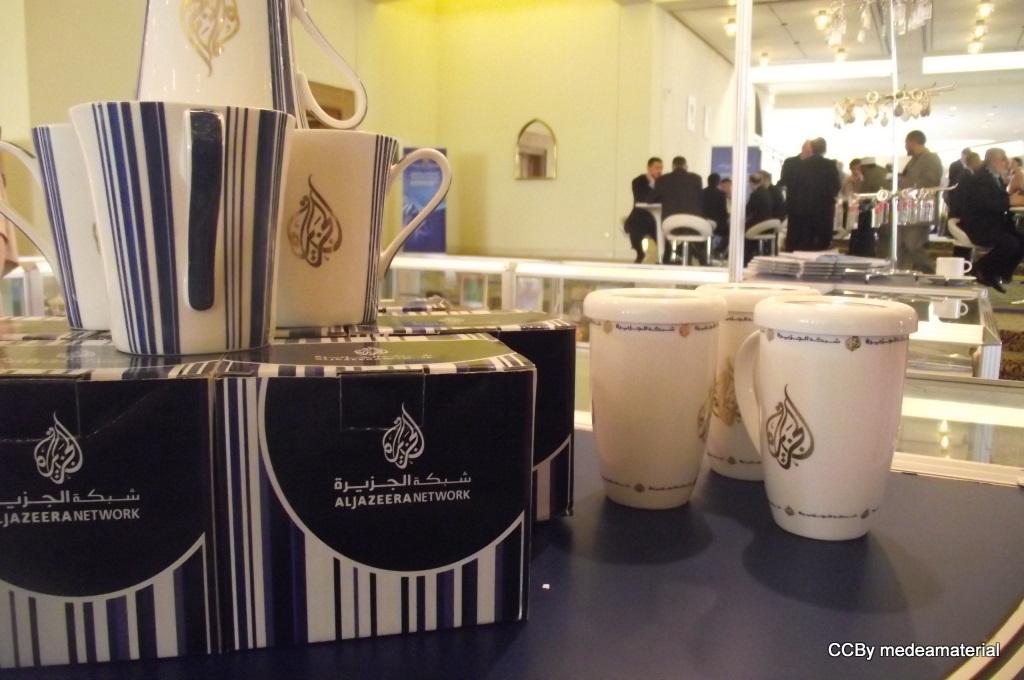What does the black box say?
Provide a short and direct response. Aljazeera network. What network is shown on the box?
Your answer should be compact. Aljazeera. 